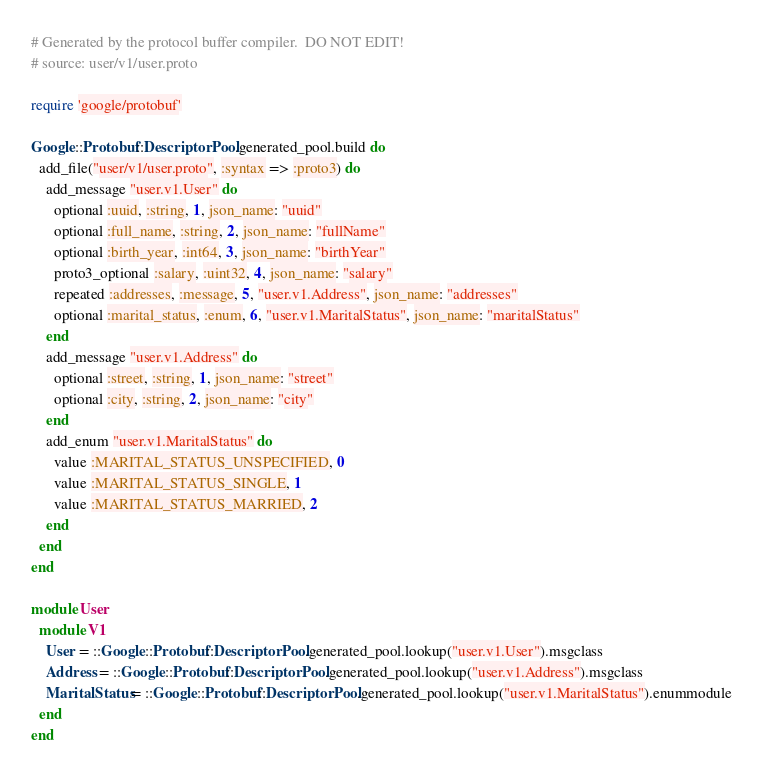<code> <loc_0><loc_0><loc_500><loc_500><_Ruby_># Generated by the protocol buffer compiler.  DO NOT EDIT!
# source: user/v1/user.proto

require 'google/protobuf'

Google::Protobuf::DescriptorPool.generated_pool.build do
  add_file("user/v1/user.proto", :syntax => :proto3) do
    add_message "user.v1.User" do
      optional :uuid, :string, 1, json_name: "uuid"
      optional :full_name, :string, 2, json_name: "fullName"
      optional :birth_year, :int64, 3, json_name: "birthYear"
      proto3_optional :salary, :uint32, 4, json_name: "salary"
      repeated :addresses, :message, 5, "user.v1.Address", json_name: "addresses"
      optional :marital_status, :enum, 6, "user.v1.MaritalStatus", json_name: "maritalStatus"
    end
    add_message "user.v1.Address" do
      optional :street, :string, 1, json_name: "street"
      optional :city, :string, 2, json_name: "city"
    end
    add_enum "user.v1.MaritalStatus" do
      value :MARITAL_STATUS_UNSPECIFIED, 0
      value :MARITAL_STATUS_SINGLE, 1
      value :MARITAL_STATUS_MARRIED, 2
    end
  end
end

module User
  module V1
    User = ::Google::Protobuf::DescriptorPool.generated_pool.lookup("user.v1.User").msgclass
    Address = ::Google::Protobuf::DescriptorPool.generated_pool.lookup("user.v1.Address").msgclass
    MaritalStatus = ::Google::Protobuf::DescriptorPool.generated_pool.lookup("user.v1.MaritalStatus").enummodule
  end
end
</code> 